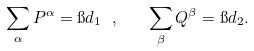Convert formula to latex. <formula><loc_0><loc_0><loc_500><loc_500>\sum _ { \alpha } P ^ { \alpha } = \i d _ { 1 } \ , \quad \sum _ { \beta } Q ^ { \beta } = \i d _ { 2 } .</formula> 